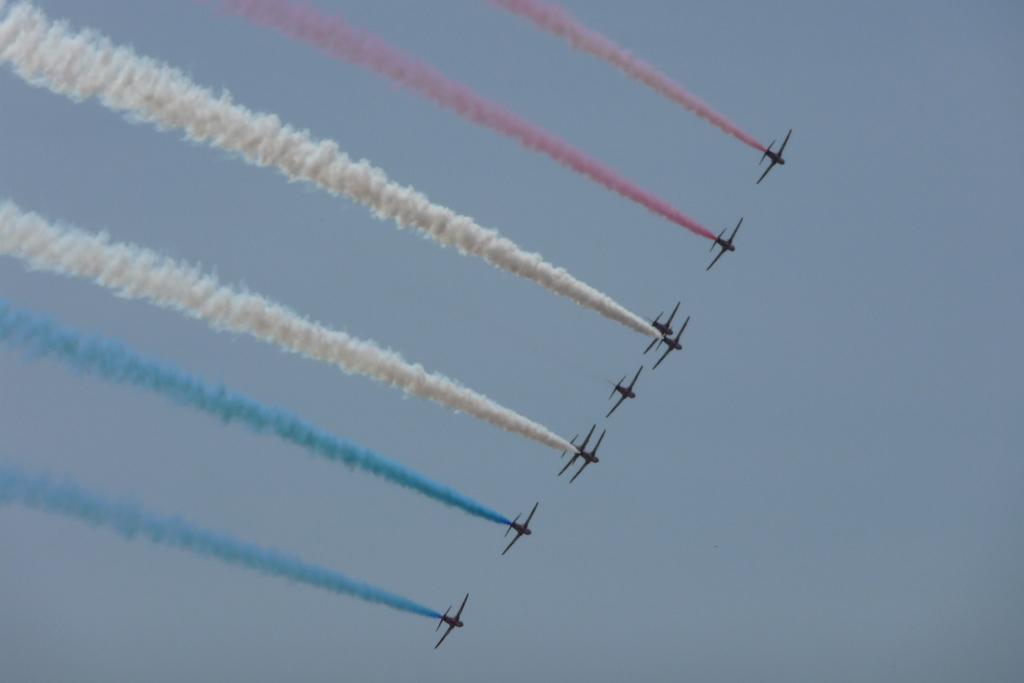Could you give a brief overview of what you see in this image? In this image few airplanes are flying in air. Few airplanes are releasing the smoke of different colours. Two planes are releasing the red colour smoke. Two planes are releasing blue colour smoke. In background there is sky. 